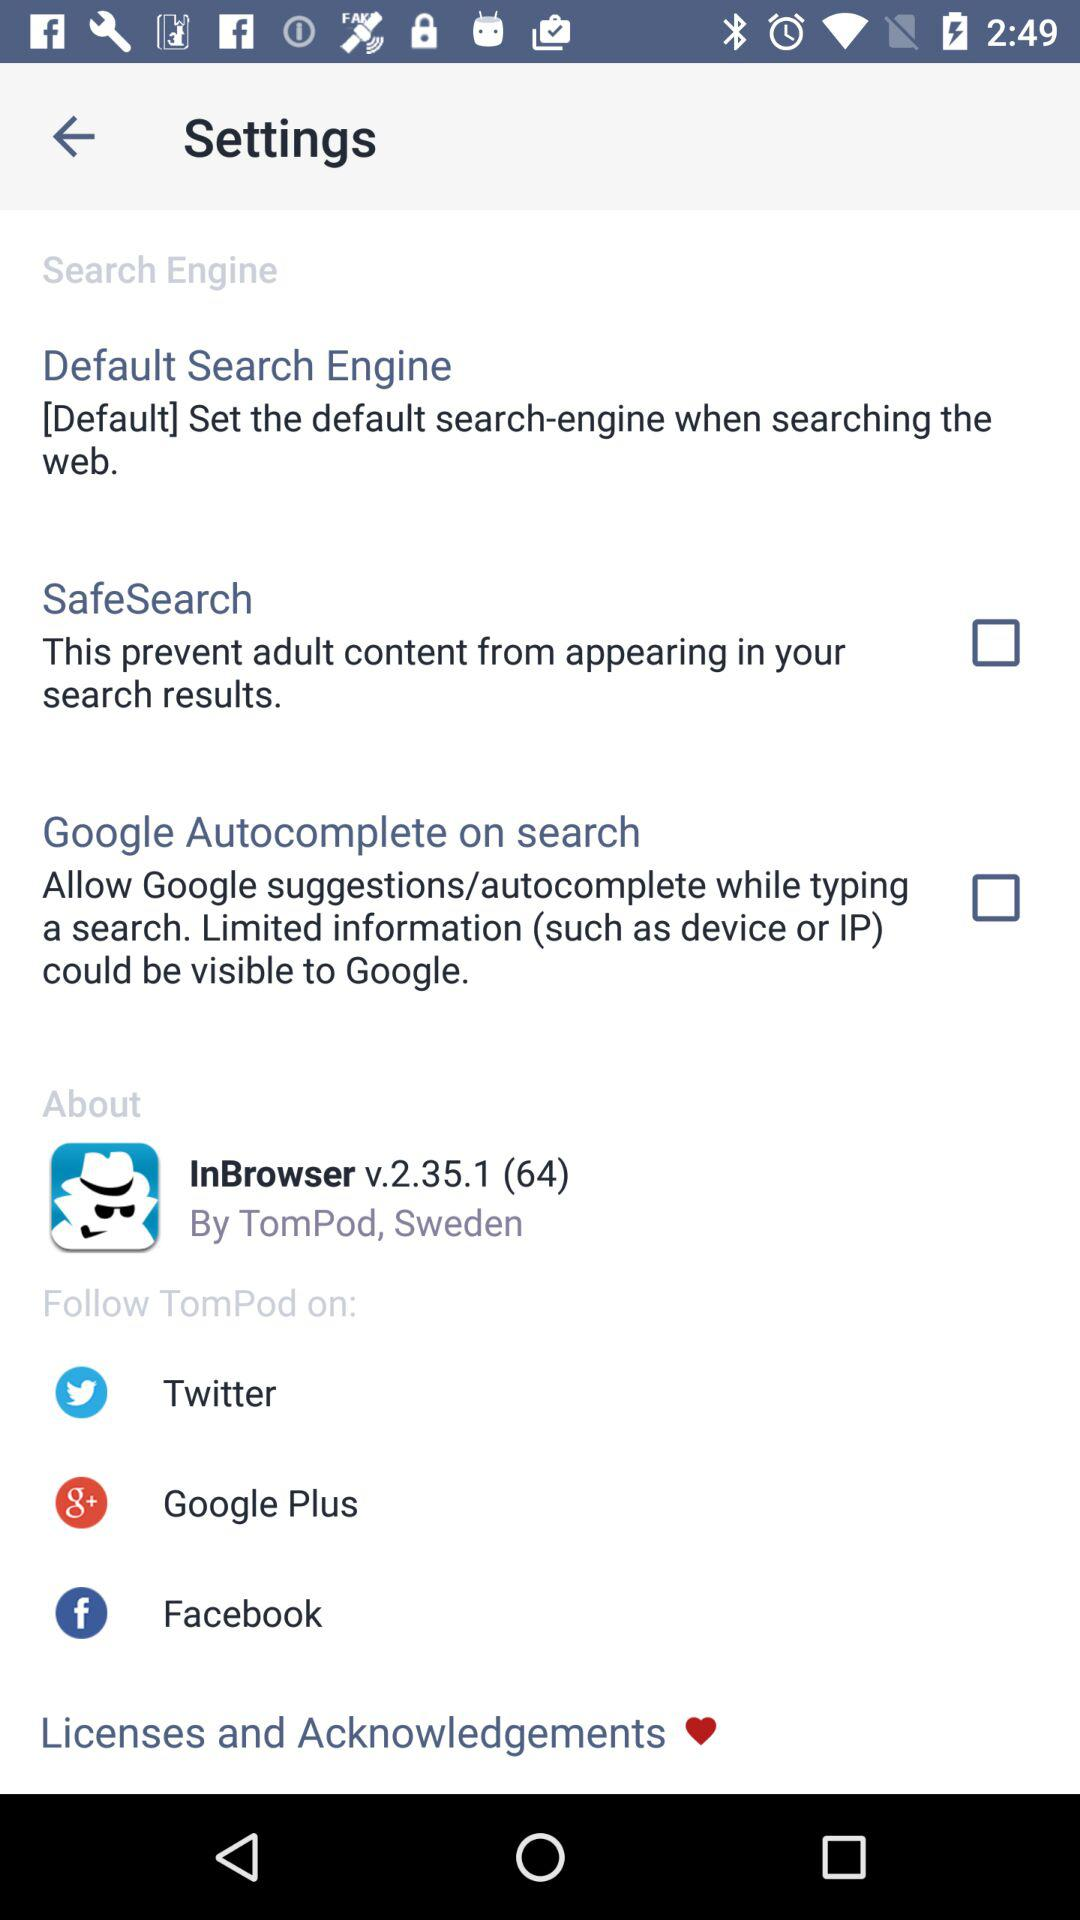Who developed "InBrowser"? "InBrowser" is developed by "TomPod". 